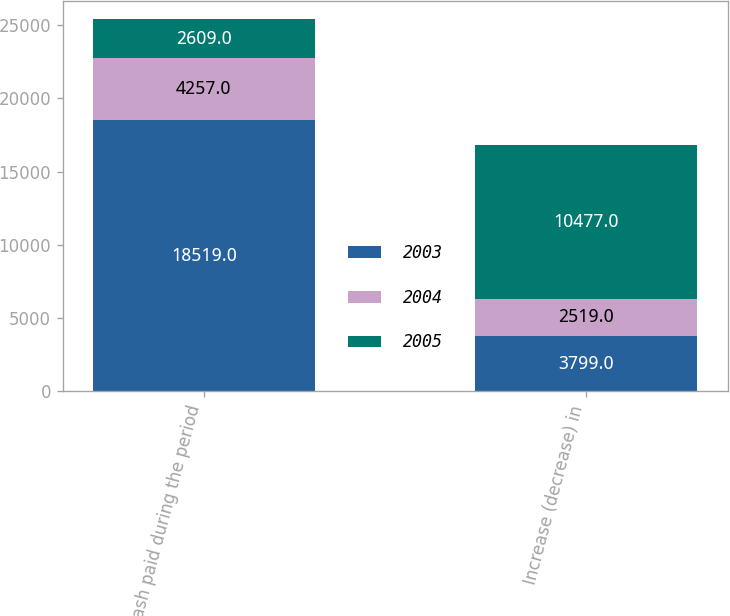Convert chart to OTSL. <chart><loc_0><loc_0><loc_500><loc_500><stacked_bar_chart><ecel><fcel>Cash paid during the period<fcel>Increase (decrease) in<nl><fcel>2003<fcel>18519<fcel>3799<nl><fcel>2004<fcel>4257<fcel>2519<nl><fcel>2005<fcel>2609<fcel>10477<nl></chart> 